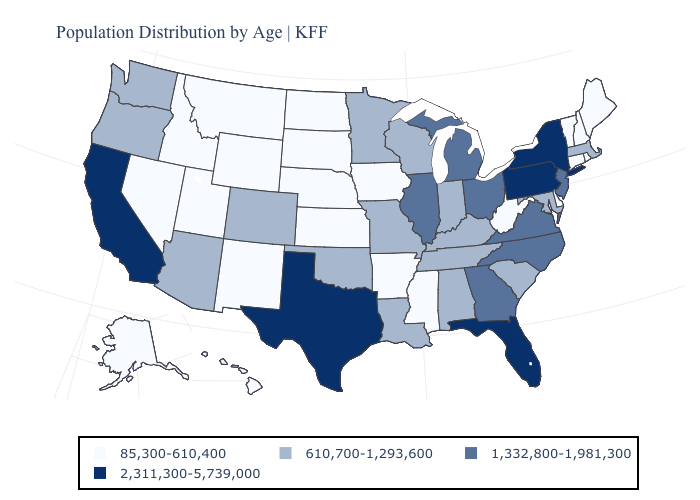What is the value of Montana?
Quick response, please. 85,300-610,400. What is the value of Utah?
Be succinct. 85,300-610,400. What is the lowest value in the USA?
Give a very brief answer. 85,300-610,400. Does Georgia have the same value as Virginia?
Quick response, please. Yes. Does Florida have the lowest value in the USA?
Write a very short answer. No. What is the highest value in the West ?
Short answer required. 2,311,300-5,739,000. What is the lowest value in the West?
Answer briefly. 85,300-610,400. Among the states that border New Jersey , which have the lowest value?
Be succinct. Delaware. Which states have the lowest value in the USA?
Quick response, please. Alaska, Arkansas, Connecticut, Delaware, Hawaii, Idaho, Iowa, Kansas, Maine, Mississippi, Montana, Nebraska, Nevada, New Hampshire, New Mexico, North Dakota, Rhode Island, South Dakota, Utah, Vermont, West Virginia, Wyoming. Which states hav the highest value in the South?
Write a very short answer. Florida, Texas. What is the value of Iowa?
Be succinct. 85,300-610,400. What is the highest value in the South ?
Quick response, please. 2,311,300-5,739,000. Name the states that have a value in the range 85,300-610,400?
Keep it brief. Alaska, Arkansas, Connecticut, Delaware, Hawaii, Idaho, Iowa, Kansas, Maine, Mississippi, Montana, Nebraska, Nevada, New Hampshire, New Mexico, North Dakota, Rhode Island, South Dakota, Utah, Vermont, West Virginia, Wyoming. Does Texas have a lower value than Michigan?
Answer briefly. No. Does Connecticut have the lowest value in the Northeast?
Answer briefly. Yes. 